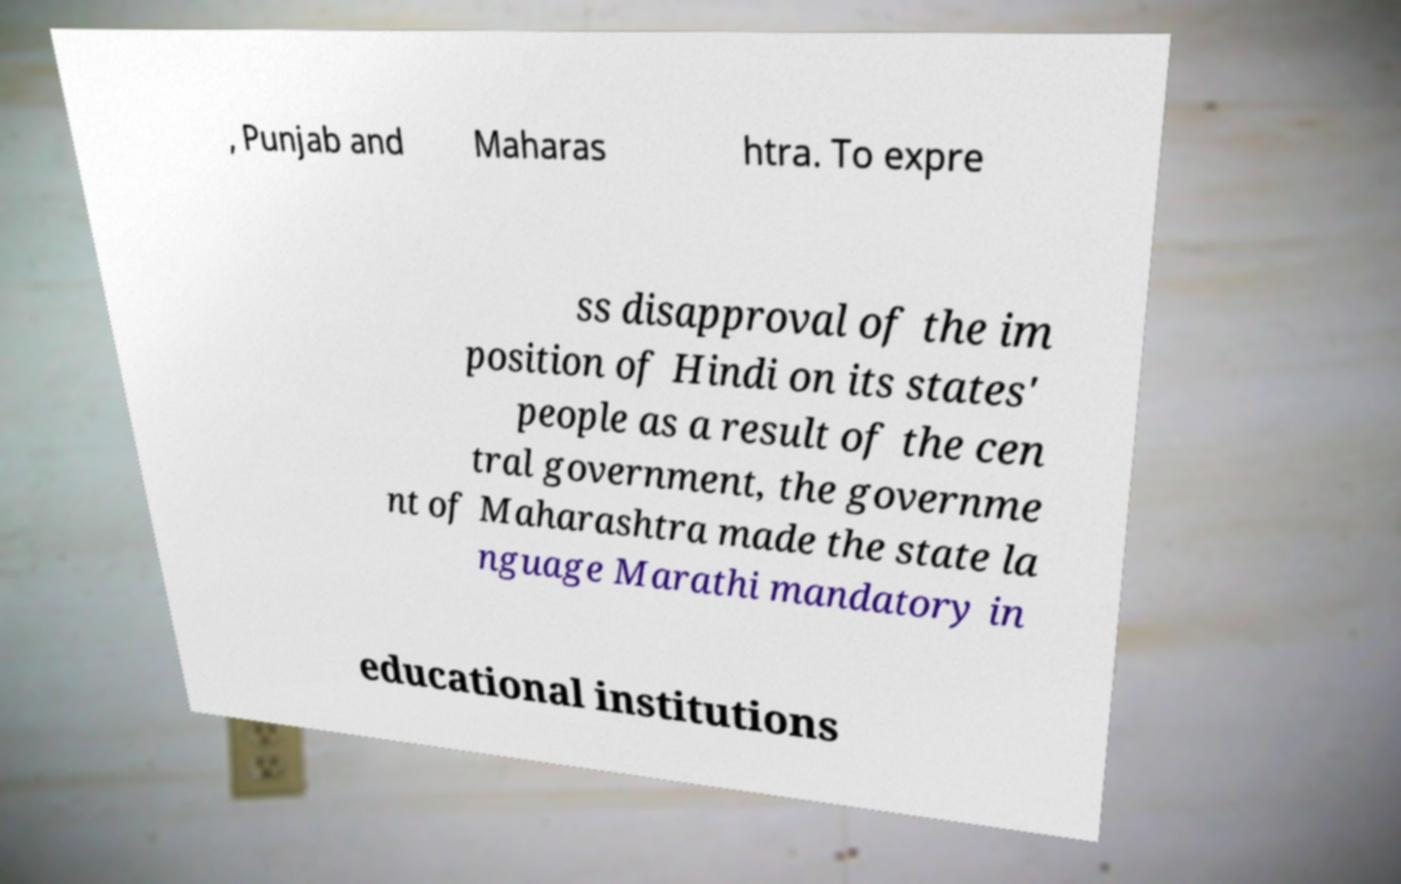Could you assist in decoding the text presented in this image and type it out clearly? , Punjab and Maharas htra. To expre ss disapproval of the im position of Hindi on its states' people as a result of the cen tral government, the governme nt of Maharashtra made the state la nguage Marathi mandatory in educational institutions 